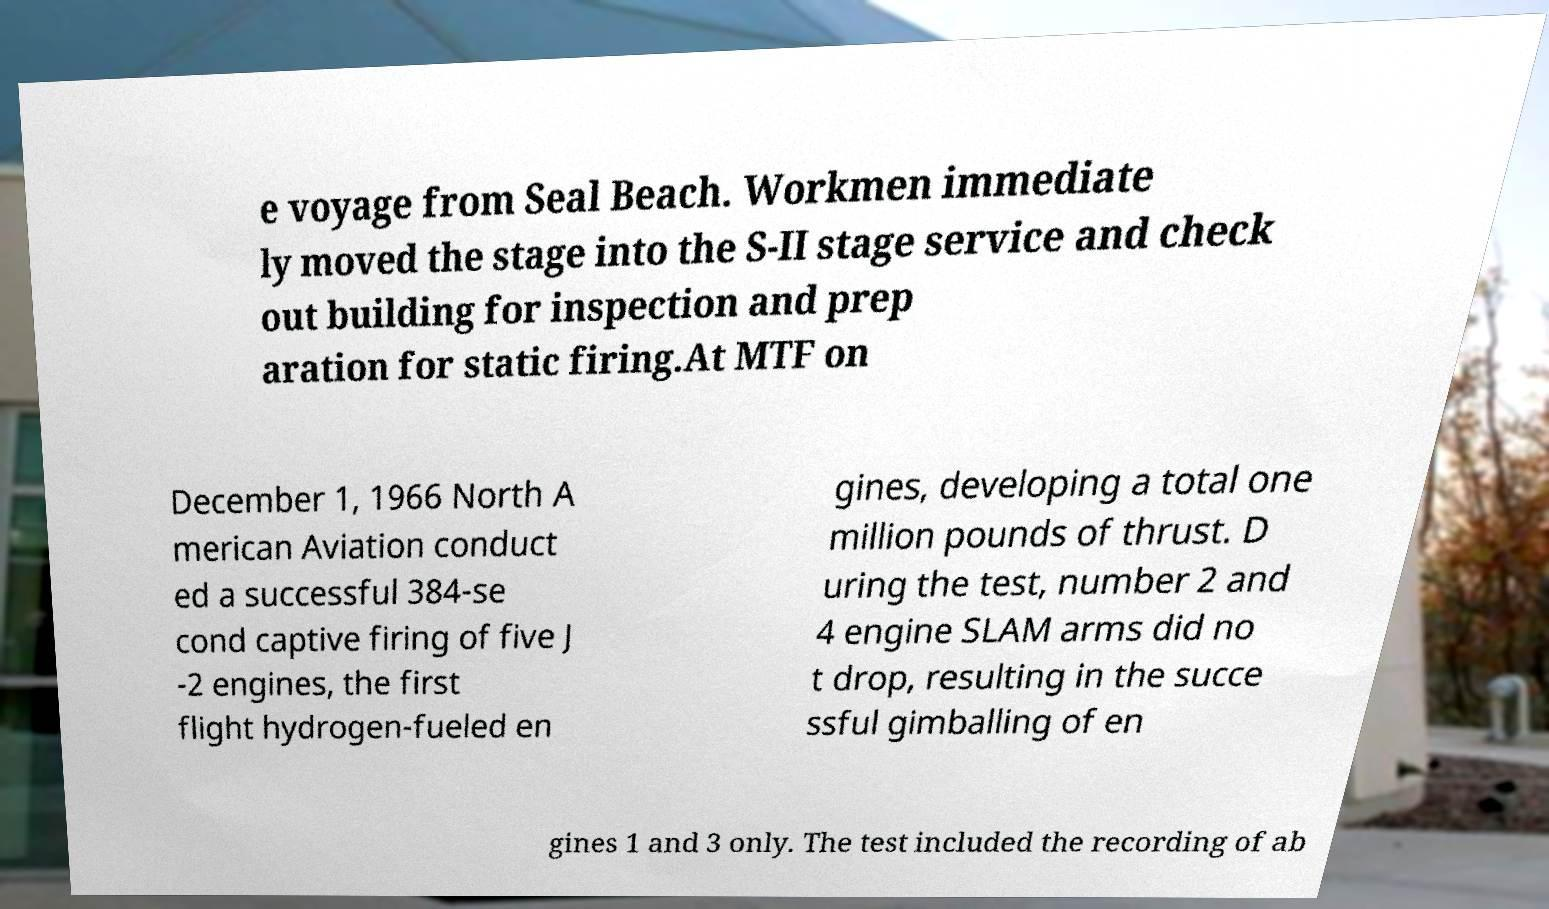For documentation purposes, I need the text within this image transcribed. Could you provide that? e voyage from Seal Beach. Workmen immediate ly moved the stage into the S-II stage service and check out building for inspection and prep aration for static firing.At MTF on December 1, 1966 North A merican Aviation conduct ed a successful 384-se cond captive firing of five J -2 engines, the first flight hydrogen-fueled en gines, developing a total one million pounds of thrust. D uring the test, number 2 and 4 engine SLAM arms did no t drop, resulting in the succe ssful gimballing of en gines 1 and 3 only. The test included the recording of ab 